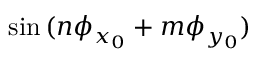Convert formula to latex. <formula><loc_0><loc_0><loc_500><loc_500>\sin { ( n \phi _ { x _ { 0 } } + m \phi _ { y _ { 0 } } ) }</formula> 